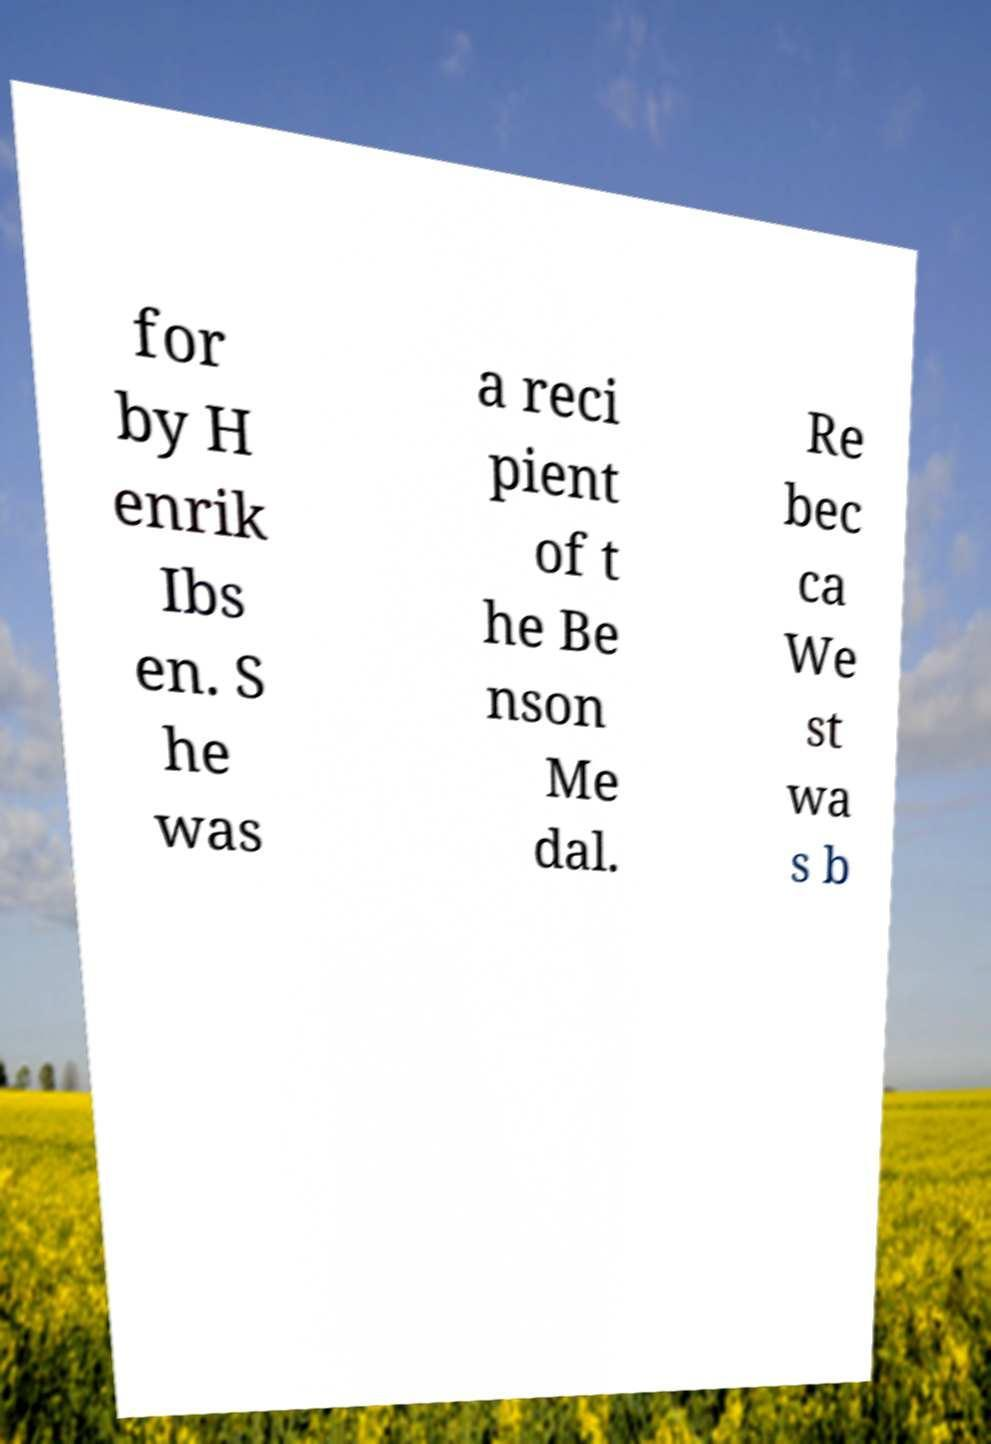Could you extract and type out the text from this image? for by H enrik Ibs en. S he was a reci pient of t he Be nson Me dal. Re bec ca We st wa s b 